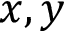Convert formula to latex. <formula><loc_0><loc_0><loc_500><loc_500>x , y</formula> 